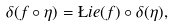Convert formula to latex. <formula><loc_0><loc_0><loc_500><loc_500>\delta ( f \circ \eta ) = \L i e ( f ) \circ \delta ( \eta ) ,</formula> 